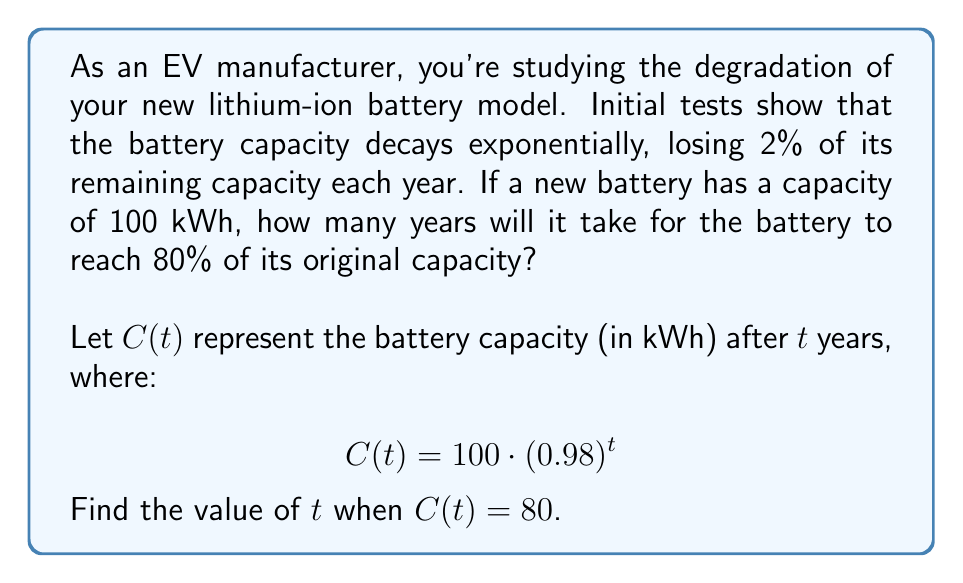Provide a solution to this math problem. To solve this problem, we need to use the exponential decay function and solve for t. Let's approach this step-by-step:

1) We start with the given equation:
   $$C(t) = 100 \cdot (0.98)^t$$

2) We want to find t when C(t) = 80, so we can set up the equation:
   $$80 = 100 \cdot (0.98)^t$$

3) Divide both sides by 100:
   $$0.8 = (0.98)^t$$

4) To solve for t, we need to take the natural logarithm of both sides:
   $$\ln(0.8) = \ln((0.98)^t)$$

5) Using the logarithm property $\ln(a^b) = b\ln(a)$, we get:
   $$\ln(0.8) = t \cdot \ln(0.98)$$

6) Now we can solve for t:
   $$t = \frac{\ln(0.8)}{\ln(0.98)}$$

7) Using a calculator or computer:
   $$t \approx 11.05$$

8) Since we're dealing with whole years, we need to round up to the next integer.

Therefore, it will take 12 years for the battery to reach 80% of its original capacity.
Answer: 12 years 